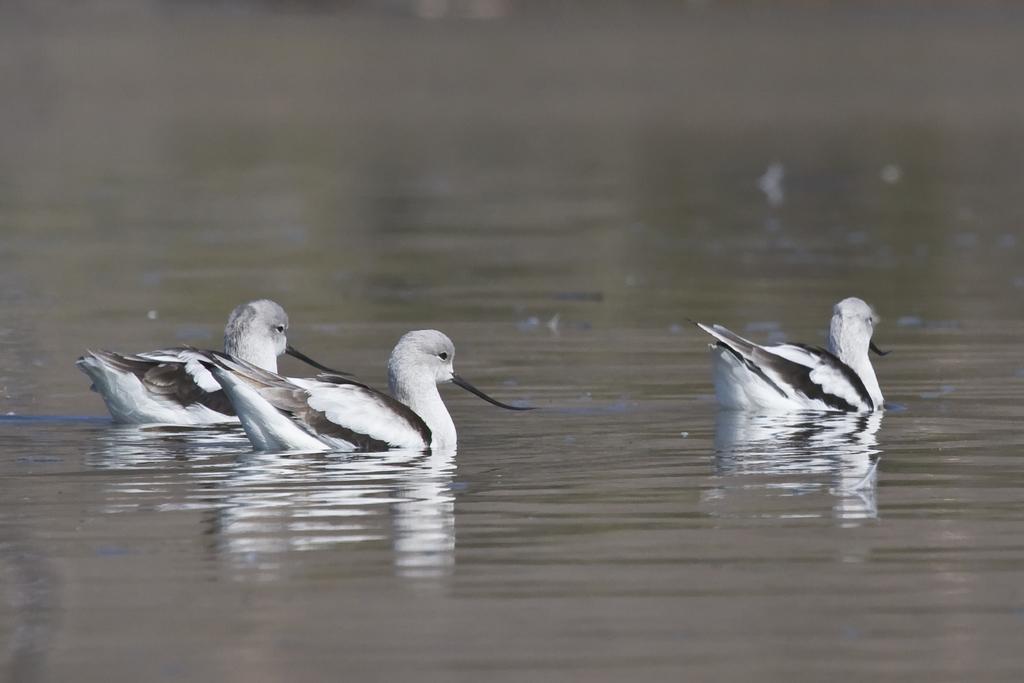Could you give a brief overview of what you see in this image? In the middle I can see three birds in the water. This image is taken may be in a lake. 